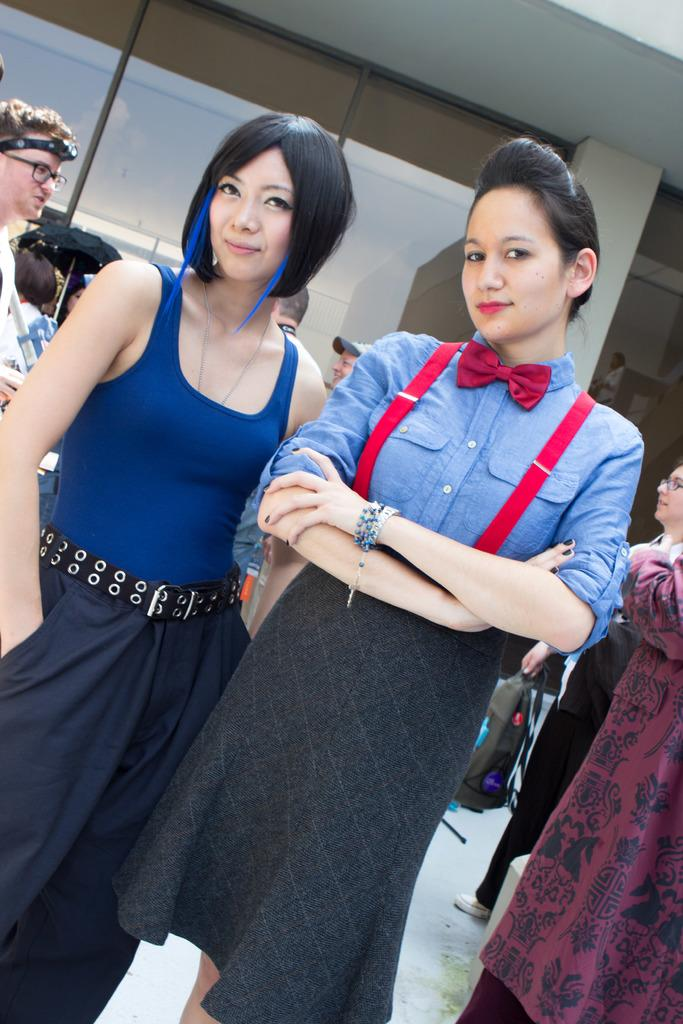How many ladies are present in the image? There are two ladies standing in the image. Can you describe the positioning of the ladies in the image? The ladies are standing in the image. Are there any other people visible in the image besides the ladies? Yes, there are a few other persons behind the ladies in the image. What type of apparatus is being used by the ladies in the image? There is no apparatus visible in the image; the ladies are simply standing. What role does gold play in the image? There is no mention of gold in the image or the provided facts. 